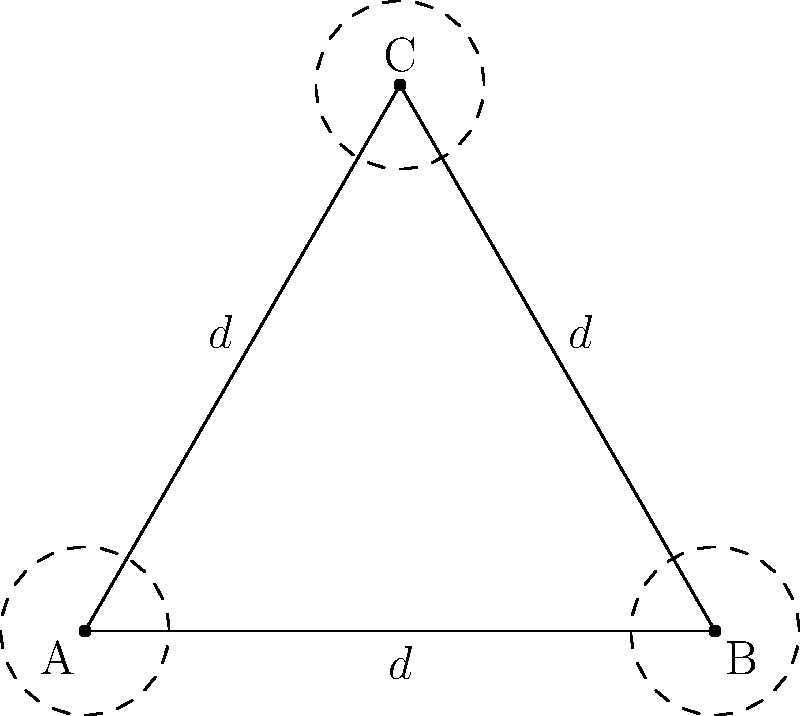In an organic garden, plants are arranged in an equilateral triangular pattern to maximize space and minimize pest issues. If each plant requires a circular space with a radius of 0.8 meters, what is the optimal distance $d$ between the centers of adjacent plants to ensure they don't overlap while minimizing wasted space? To find the optimal spacing between plants, we need to determine the side length of the equilateral triangle formed by the centers of three adjacent plants. This distance will be equal to the diameter of the circular space each plant requires.

Steps to solve:
1. The radius of each plant's required space is 0.8 meters.
2. The diameter of this space is twice the radius: $2 * 0.8 = 1.6$ meters.
3. In an optimal arrangement, the plants will be touching at the edges of their circular spaces.
4. Therefore, the distance $d$ between the centers of adjacent plants is equal to the diameter of the circular space.

Thus, the optimal distance $d$ between the centers of adjacent plants is 1.6 meters.

This arrangement ensures that:
a) The plants don't overlap, as their centers are separated by the sum of their radii.
b) There is minimal wasted space between plants, as they are as close as possible without overlapping.
Answer: $d = 1.6$ meters 